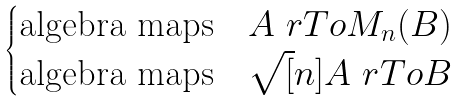<formula> <loc_0><loc_0><loc_500><loc_500>\begin{cases} \text {algebra maps} \quad A \ r T o M _ { n } ( B ) \\ \text {algebra maps} \quad \sqrt { [ } n ] { A } \ r T o B \end{cases}</formula> 